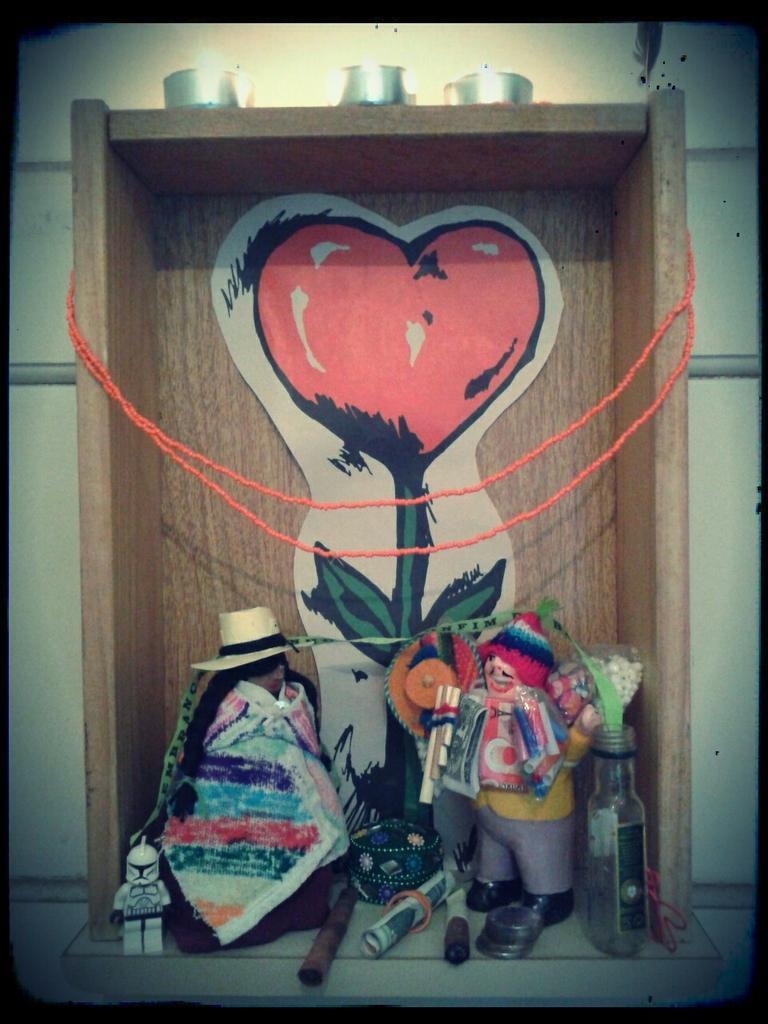Could you give a brief overview of what you see in this image? In this picture, we can see some objects on the ground, like toys, rope, wooden object with an art, we can see the wall. 